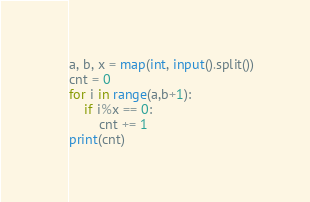<code> <loc_0><loc_0><loc_500><loc_500><_Python_>a, b, x = map(int, input().split())
cnt = 0
for i in range(a,b+1):
    if i%x == 0:
        cnt += 1
print(cnt)</code> 